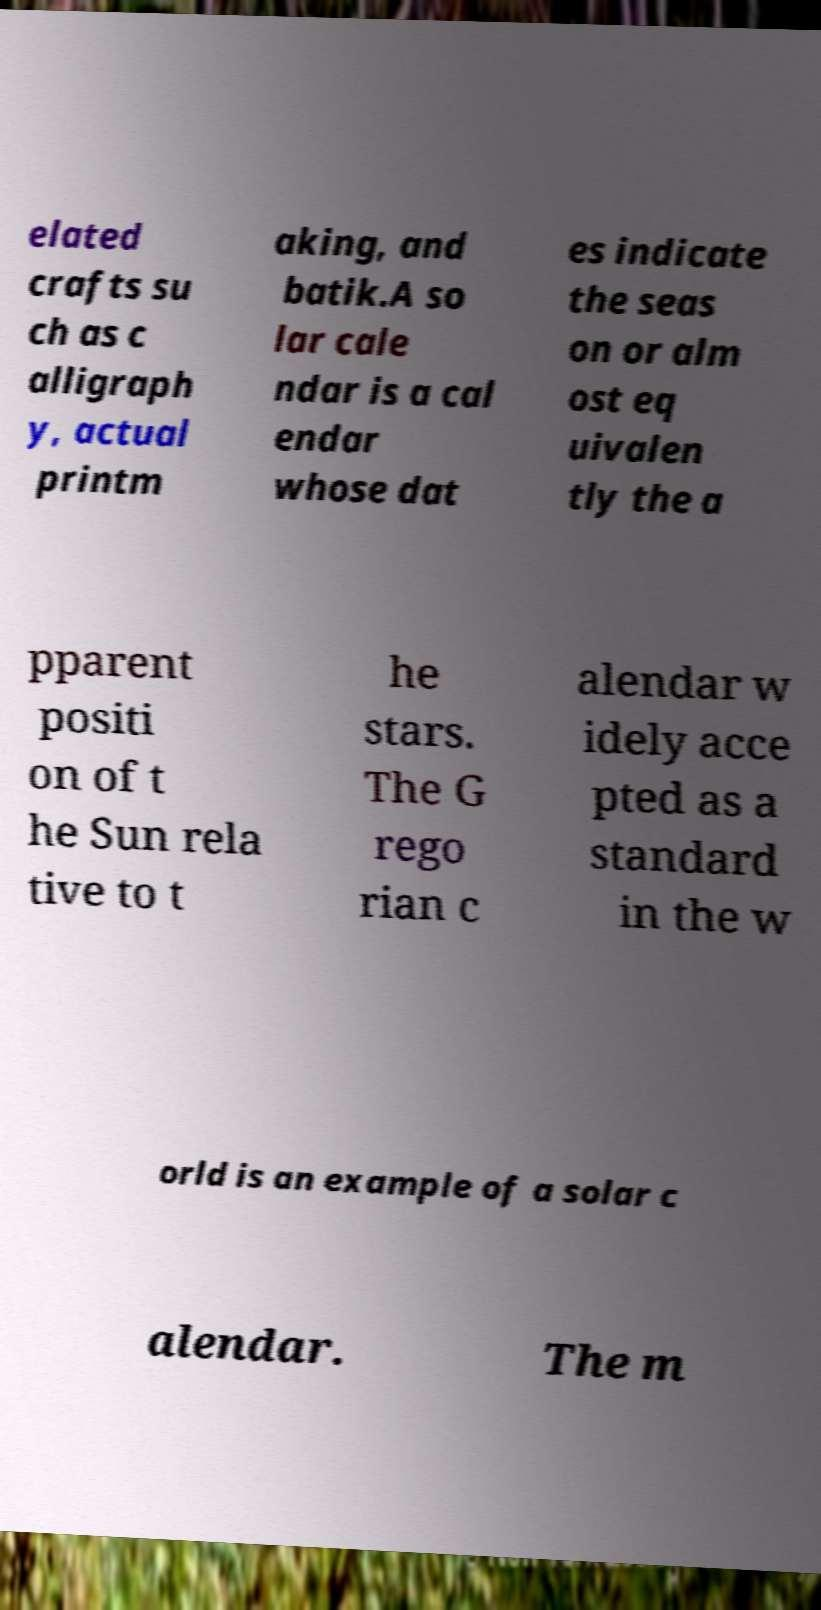Please identify and transcribe the text found in this image. elated crafts su ch as c alligraph y, actual printm aking, and batik.A so lar cale ndar is a cal endar whose dat es indicate the seas on or alm ost eq uivalen tly the a pparent positi on of t he Sun rela tive to t he stars. The G rego rian c alendar w idely acce pted as a standard in the w orld is an example of a solar c alendar. The m 